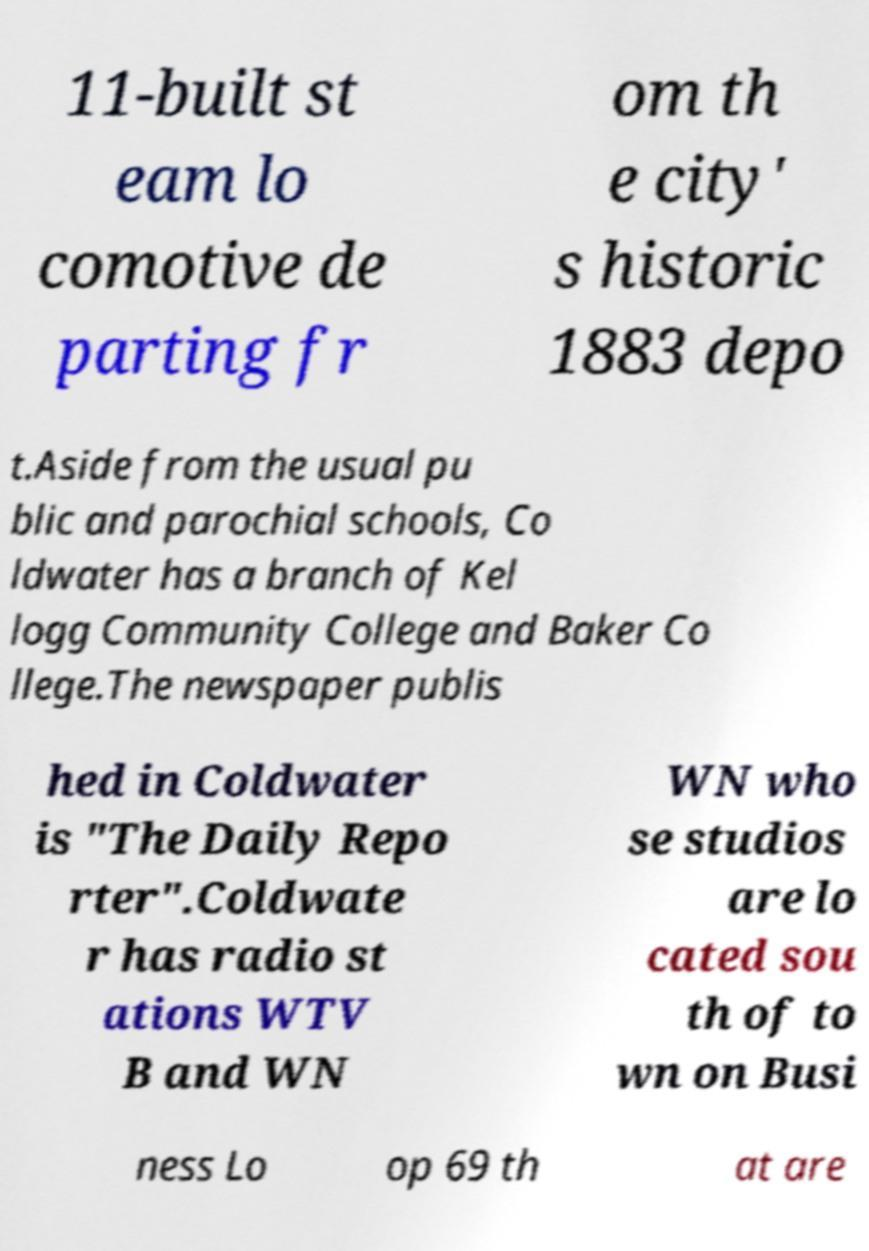Please read and relay the text visible in this image. What does it say? 11-built st eam lo comotive de parting fr om th e city' s historic 1883 depo t.Aside from the usual pu blic and parochial schools, Co ldwater has a branch of Kel logg Community College and Baker Co llege.The newspaper publis hed in Coldwater is "The Daily Repo rter".Coldwate r has radio st ations WTV B and WN WN who se studios are lo cated sou th of to wn on Busi ness Lo op 69 th at are 